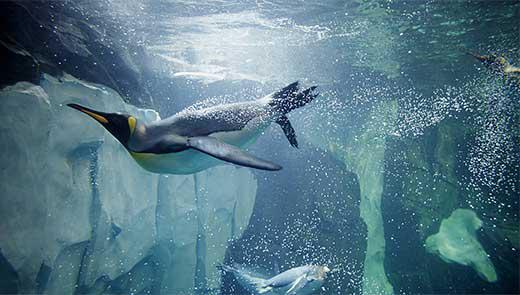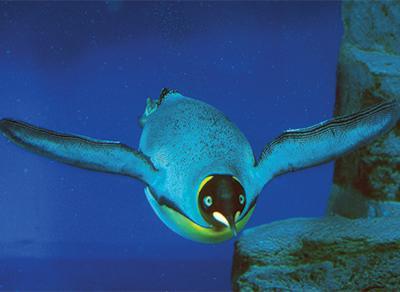The first image is the image on the left, the second image is the image on the right. Evaluate the accuracy of this statement regarding the images: "There are more than 10 penguins swimming.". Is it true? Answer yes or no. No. 